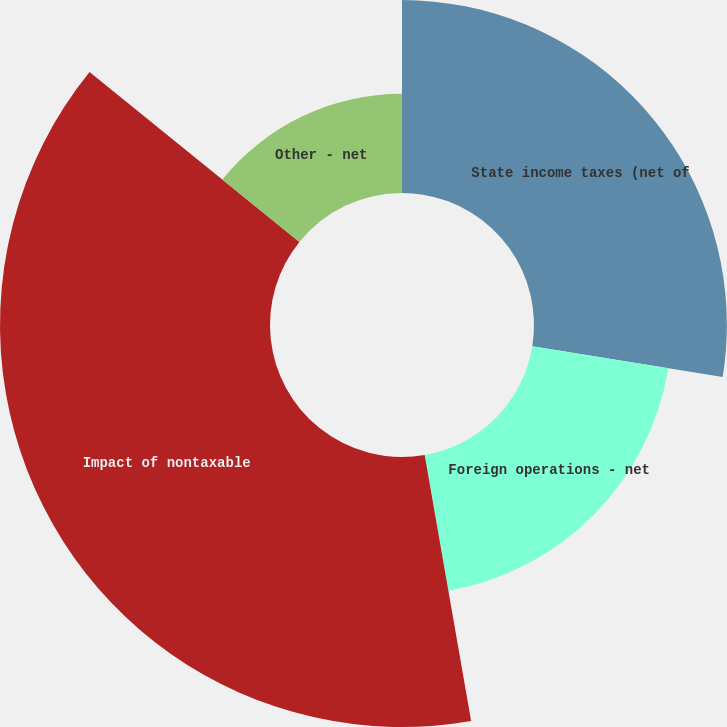Convert chart. <chart><loc_0><loc_0><loc_500><loc_500><pie_chart><fcel>State income taxes (net of<fcel>Foreign operations - net<fcel>Impact of nontaxable<fcel>Other - net<nl><fcel>27.56%<fcel>19.69%<fcel>38.58%<fcel>14.17%<nl></chart> 